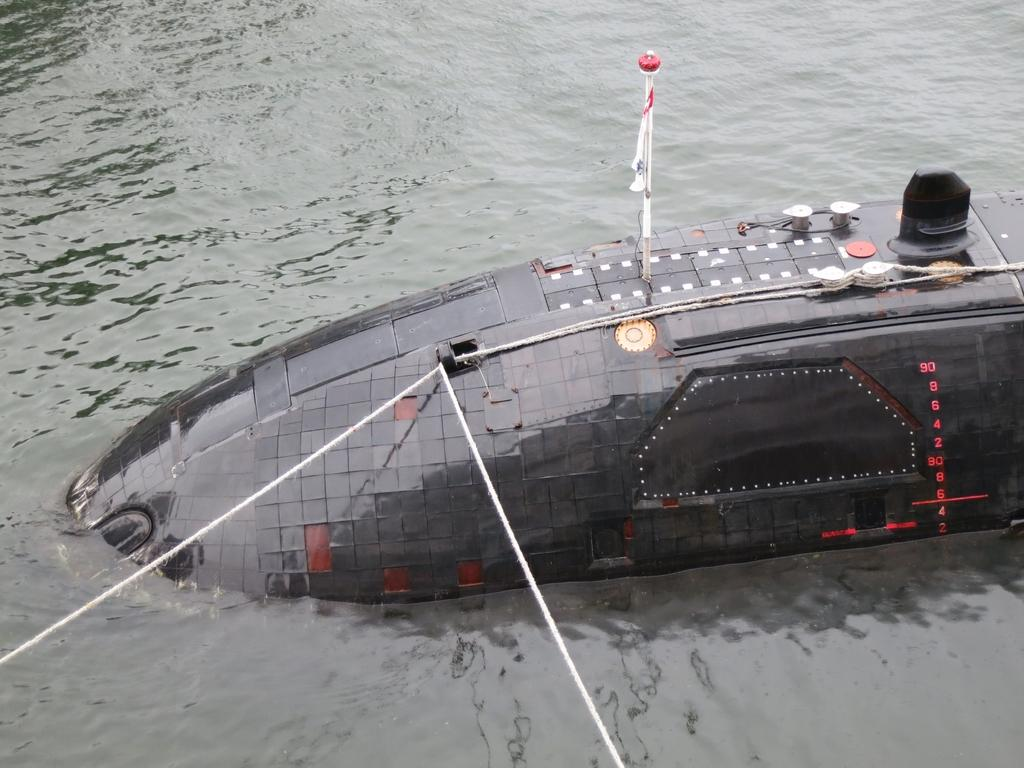What is the main subject of the image? The main subject of the image is a submarine. Where is the submarine located in the image? The submarine is floating in the ocean. What else can be seen in the image besides the submarine? There is a flag in the image. How many ladybugs can be seen crawling on the submarine in the image? There are no ladybugs present in the image; it features a submarine floating in the ocean and a flag. What type of answer can be found in the image? There is no answer present in the image; it is a visual representation of a submarine, ocean, and flag. 